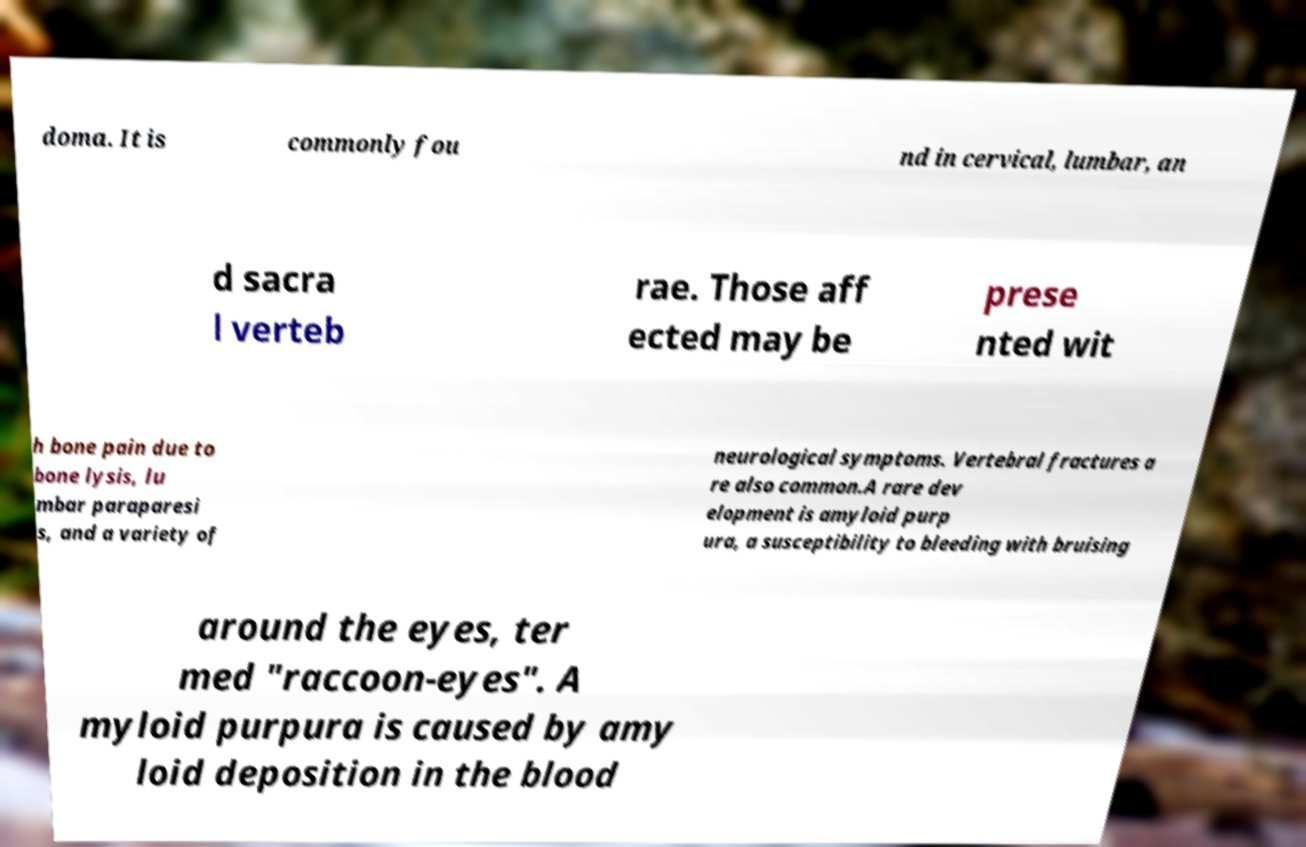Please read and relay the text visible in this image. What does it say? doma. It is commonly fou nd in cervical, lumbar, an d sacra l verteb rae. Those aff ected may be prese nted wit h bone pain due to bone lysis, lu mbar paraparesi s, and a variety of neurological symptoms. Vertebral fractures a re also common.A rare dev elopment is amyloid purp ura, a susceptibility to bleeding with bruising around the eyes, ter med "raccoon-eyes". A myloid purpura is caused by amy loid deposition in the blood 